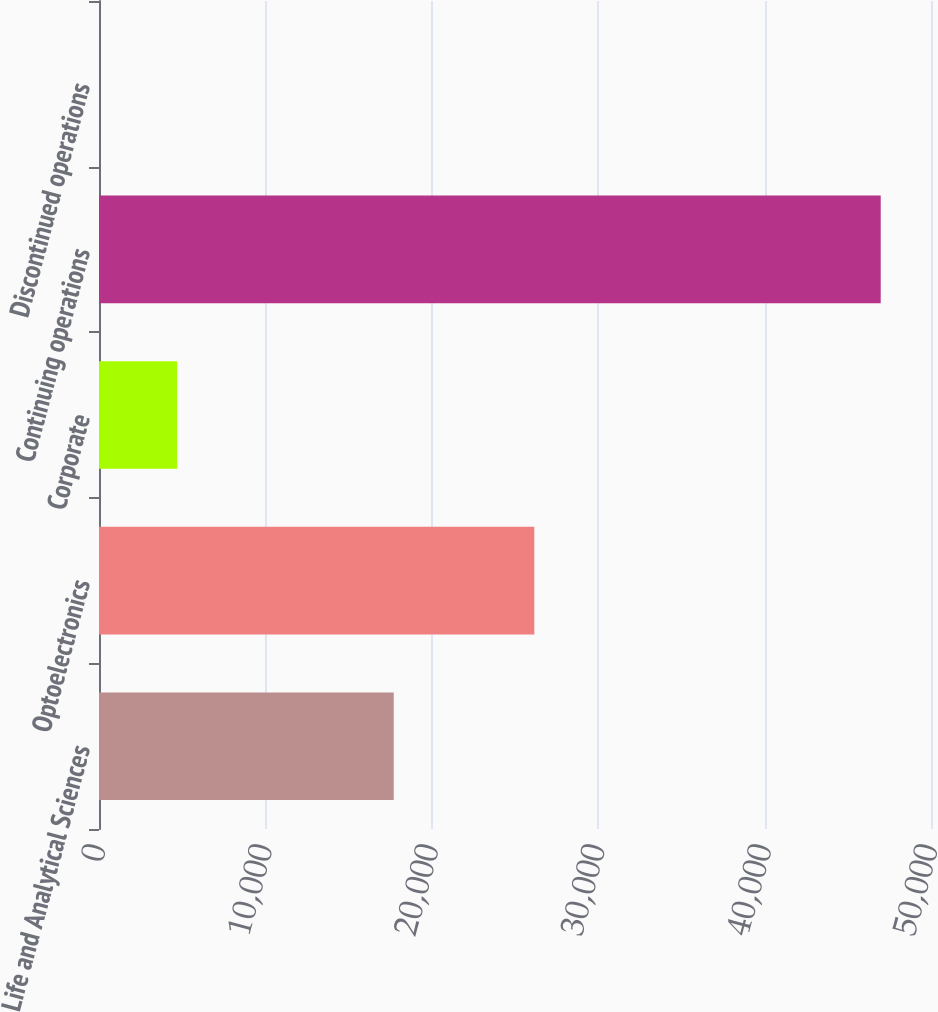<chart> <loc_0><loc_0><loc_500><loc_500><bar_chart><fcel>Life and Analytical Sciences<fcel>Optoelectronics<fcel>Corporate<fcel>Continuing operations<fcel>Discontinued operations<nl><fcel>17713<fcel>26160<fcel>4699.6<fcel>46978<fcel>2<nl></chart> 